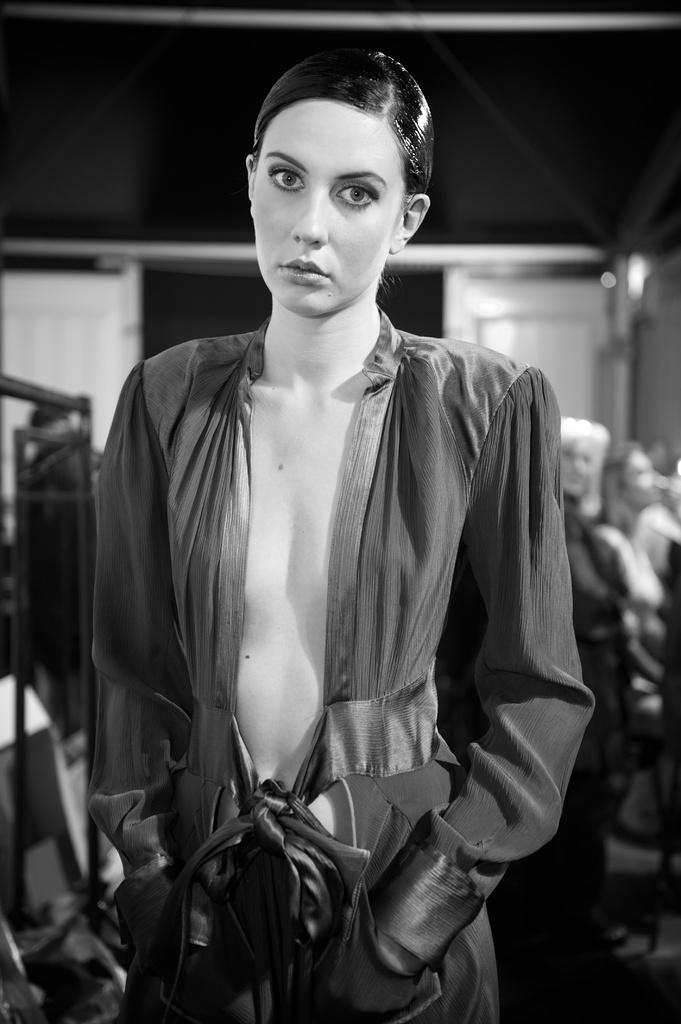What is the main subject of the image? There is a woman standing in the image. Can you describe the setting of the image? There are other people in the background of the image. What is the color scheme of the image? The image is black and white. What type of machine is being used by the woman in the image? There is no machine visible in the image; it features a woman standing and people in the background. How does the woman's throat appear in the image? The image is black and white, and there is no specific focus on the woman's throat. 